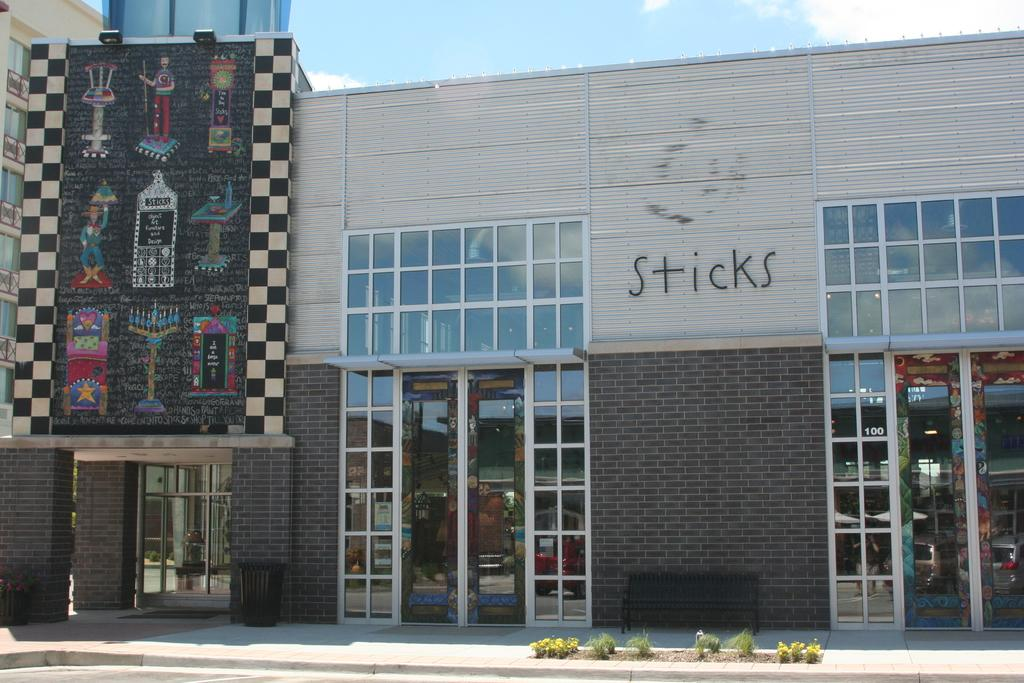<image>
Write a terse but informative summary of the picture. The building that houses Sticks has a colorful banner over the entrance. 